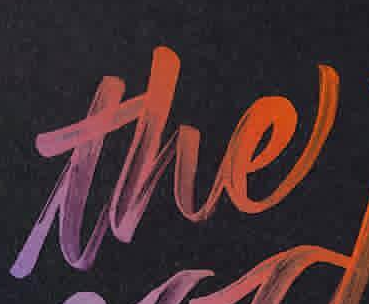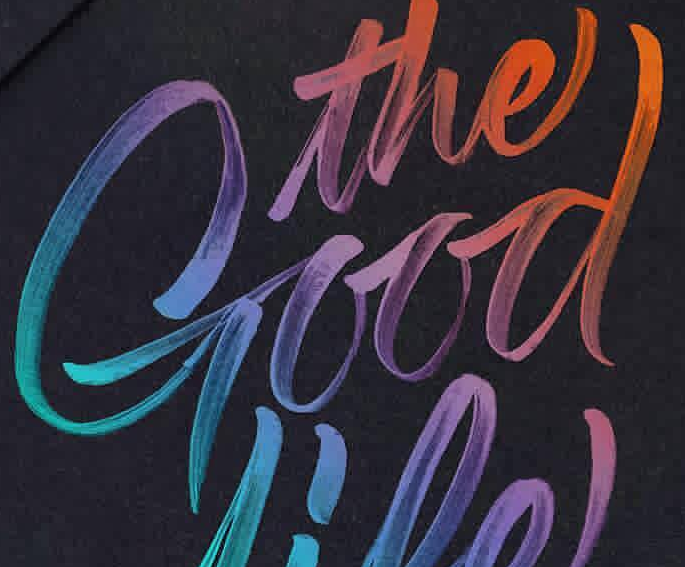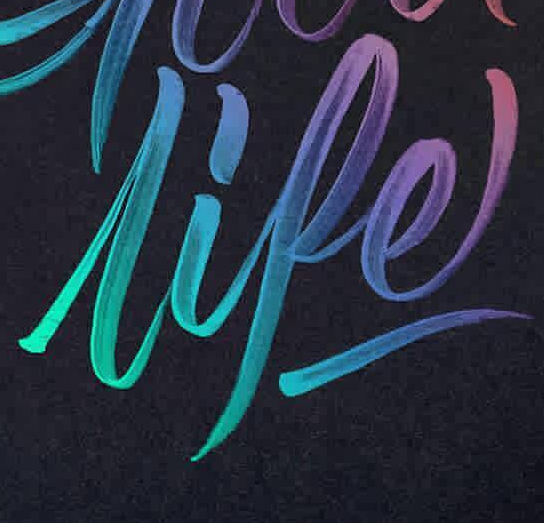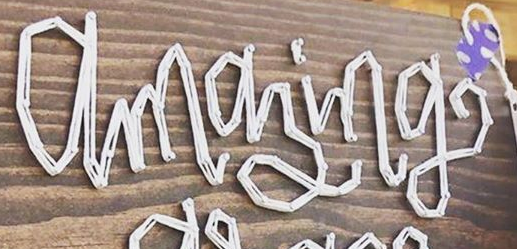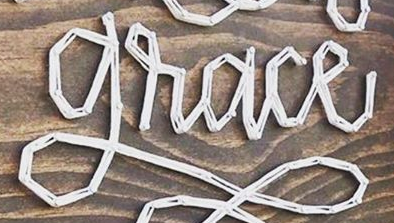Identify the words shown in these images in order, separated by a semicolon. the; Good; lipe; amazing; grace 